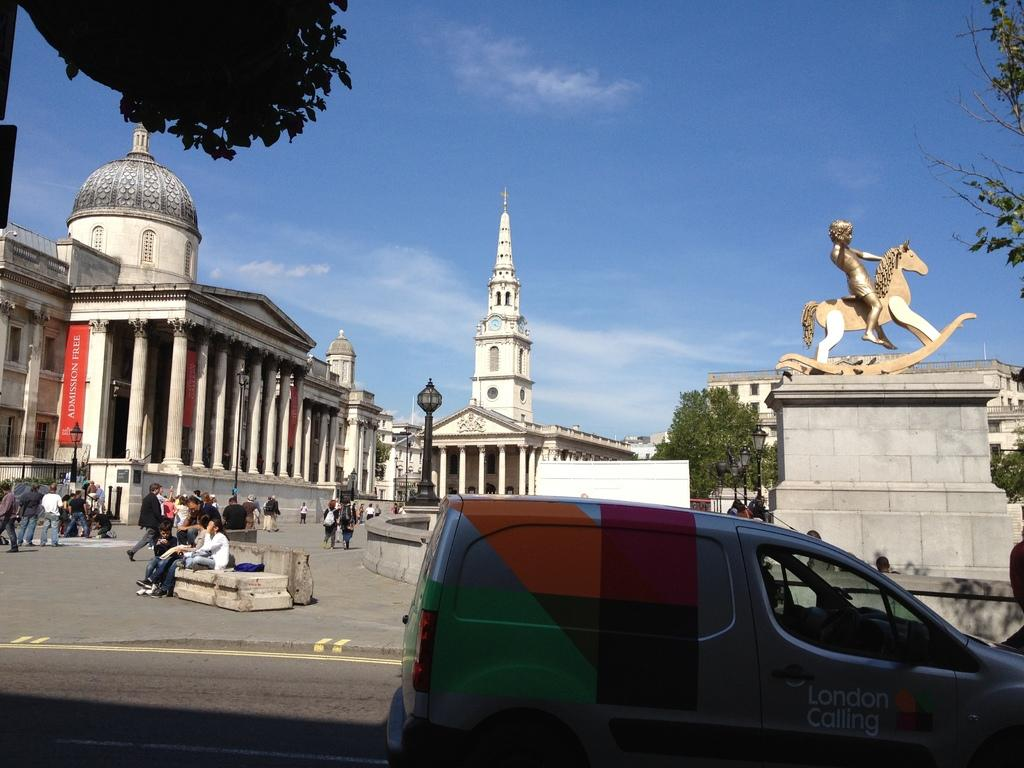What is the main subject in the image? There is a vehicle in the image. Are there any living beings present in the image? Yes, there are people in the image. What type of structures can be seen in the image? There are buildings, towers, and a statue in the image. What other objects can be seen in the image? There are trees, poles, and a statue in the image. What type of jam is being spread on the statue in the image? There is no jam present in the image, and the statue is not being used for spreading jam. 